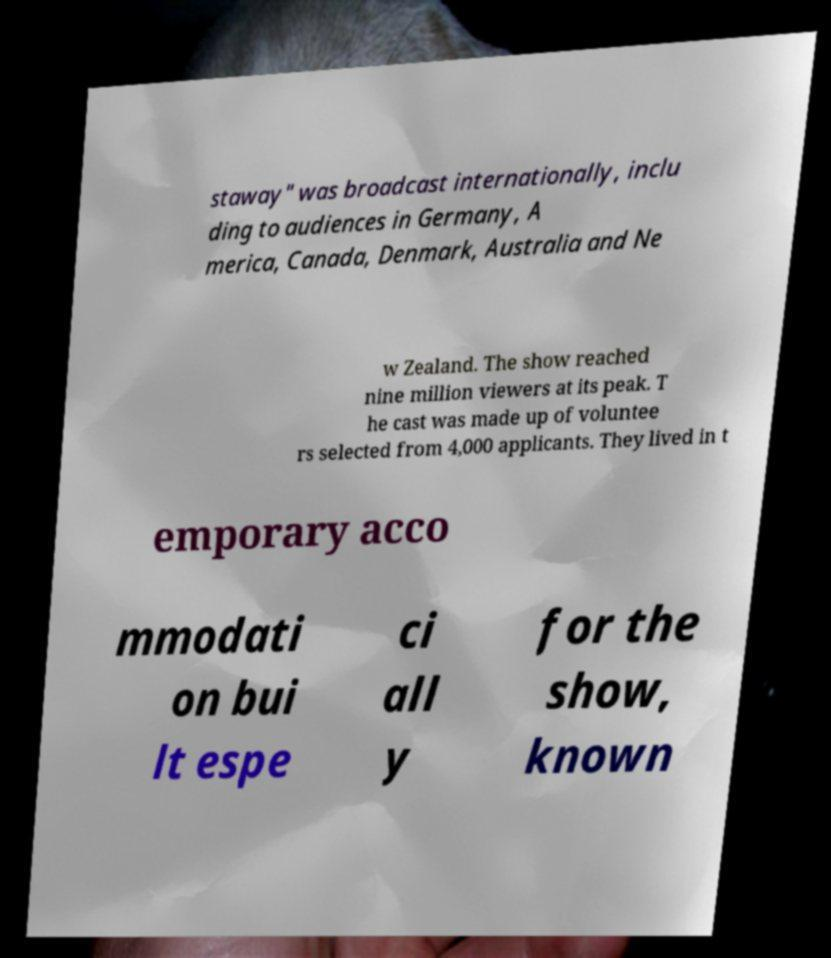There's text embedded in this image that I need extracted. Can you transcribe it verbatim? staway" was broadcast internationally, inclu ding to audiences in Germany, A merica, Canada, Denmark, Australia and Ne w Zealand. The show reached nine million viewers at its peak. T he cast was made up of voluntee rs selected from 4,000 applicants. They lived in t emporary acco mmodati on bui lt espe ci all y for the show, known 